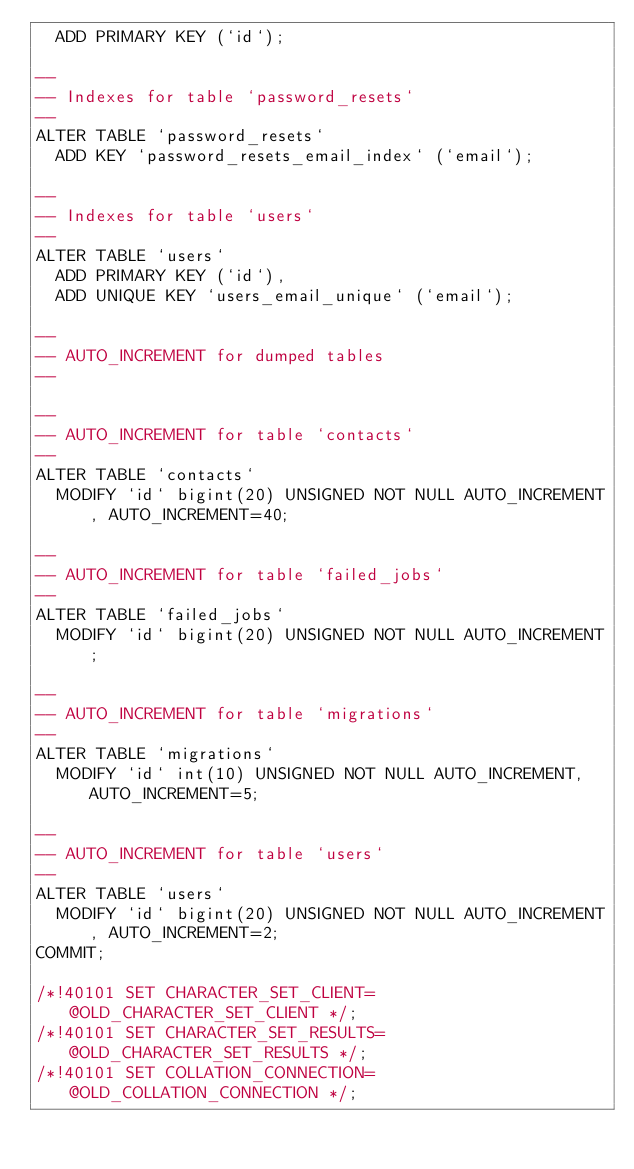Convert code to text. <code><loc_0><loc_0><loc_500><loc_500><_SQL_>  ADD PRIMARY KEY (`id`);

--
-- Indexes for table `password_resets`
--
ALTER TABLE `password_resets`
  ADD KEY `password_resets_email_index` (`email`);

--
-- Indexes for table `users`
--
ALTER TABLE `users`
  ADD PRIMARY KEY (`id`),
  ADD UNIQUE KEY `users_email_unique` (`email`);

--
-- AUTO_INCREMENT for dumped tables
--

--
-- AUTO_INCREMENT for table `contacts`
--
ALTER TABLE `contacts`
  MODIFY `id` bigint(20) UNSIGNED NOT NULL AUTO_INCREMENT, AUTO_INCREMENT=40;

--
-- AUTO_INCREMENT for table `failed_jobs`
--
ALTER TABLE `failed_jobs`
  MODIFY `id` bigint(20) UNSIGNED NOT NULL AUTO_INCREMENT;

--
-- AUTO_INCREMENT for table `migrations`
--
ALTER TABLE `migrations`
  MODIFY `id` int(10) UNSIGNED NOT NULL AUTO_INCREMENT, AUTO_INCREMENT=5;

--
-- AUTO_INCREMENT for table `users`
--
ALTER TABLE `users`
  MODIFY `id` bigint(20) UNSIGNED NOT NULL AUTO_INCREMENT, AUTO_INCREMENT=2;
COMMIT;

/*!40101 SET CHARACTER_SET_CLIENT=@OLD_CHARACTER_SET_CLIENT */;
/*!40101 SET CHARACTER_SET_RESULTS=@OLD_CHARACTER_SET_RESULTS */;
/*!40101 SET COLLATION_CONNECTION=@OLD_COLLATION_CONNECTION */;
</code> 